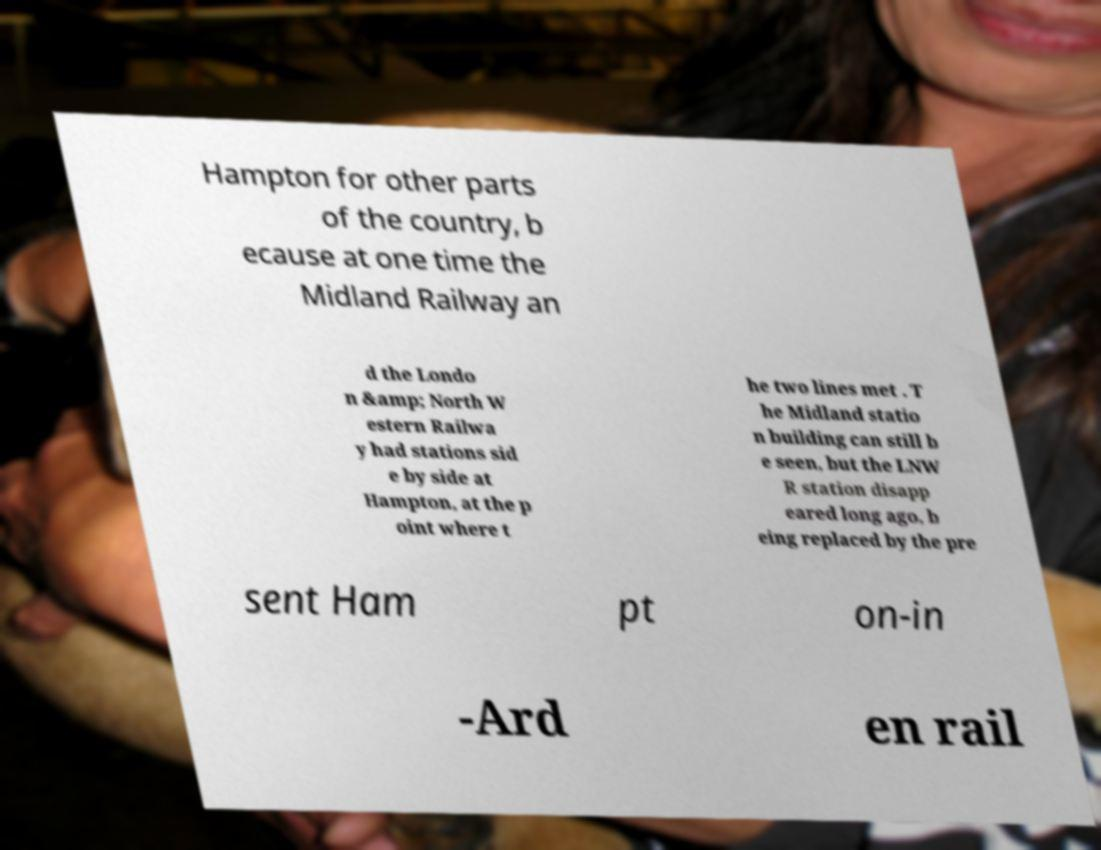Can you read and provide the text displayed in the image?This photo seems to have some interesting text. Can you extract and type it out for me? Hampton for other parts of the country, b ecause at one time the Midland Railway an d the Londo n &amp; North W estern Railwa y had stations sid e by side at Hampton, at the p oint where t he two lines met . T he Midland statio n building can still b e seen, but the LNW R station disapp eared long ago, b eing replaced by the pre sent Ham pt on-in -Ard en rail 